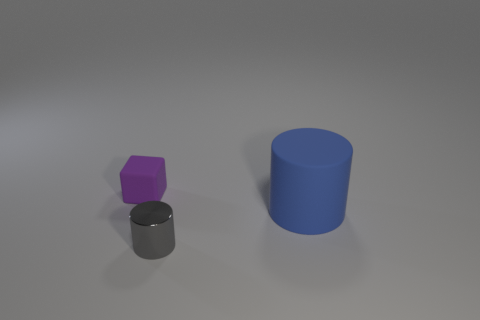Add 2 tiny purple matte things. How many objects exist? 5 Subtract all blocks. How many objects are left? 2 Subtract all shiny objects. Subtract all large green metal cylinders. How many objects are left? 2 Add 1 large objects. How many large objects are left? 2 Add 3 large blue objects. How many large blue objects exist? 4 Subtract 1 blue cylinders. How many objects are left? 2 